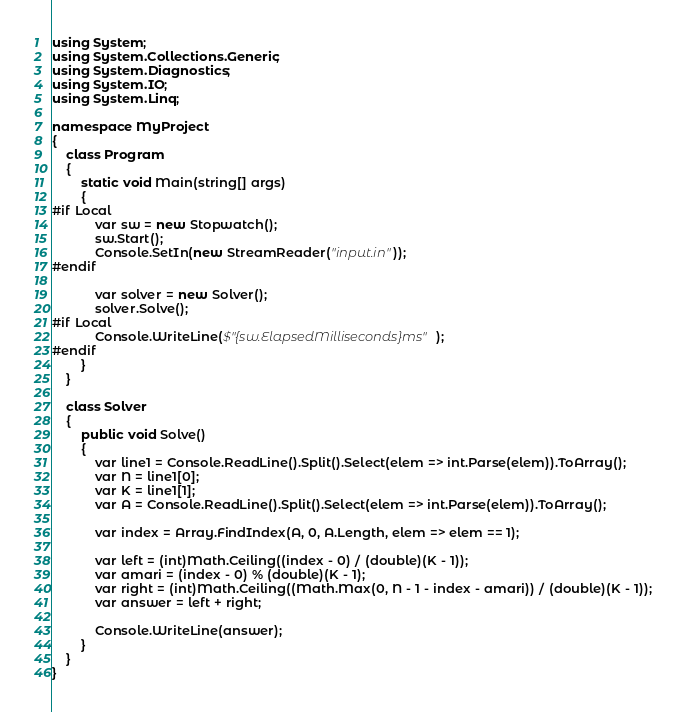<code> <loc_0><loc_0><loc_500><loc_500><_C#_>using System;
using System.Collections.Generic;
using System.Diagnostics;
using System.IO;
using System.Linq;

namespace MyProject
{
    class Program
    {
        static void Main(string[] args)
        {
#if Local
            var sw = new Stopwatch();
            sw.Start();
            Console.SetIn(new StreamReader("input.in"));
#endif

            var solver = new Solver();
            solver.Solve();
#if Local
            Console.WriteLine($"{sw.ElapsedMilliseconds}ms");
#endif
        }
    }

    class Solver
    {
        public void Solve()
        {
            var line1 = Console.ReadLine().Split().Select(elem => int.Parse(elem)).ToArray();
            var N = line1[0];
            var K = line1[1];
            var A = Console.ReadLine().Split().Select(elem => int.Parse(elem)).ToArray();

            var index = Array.FindIndex(A, 0, A.Length, elem => elem == 1);

            var left = (int)Math.Ceiling((index - 0) / (double)(K - 1));
            var amari = (index - 0) % (double)(K - 1);
            var right = (int)Math.Ceiling((Math.Max(0, N - 1 - index - amari)) / (double)(K - 1));
            var answer = left + right;

            Console.WriteLine(answer);
        }
    }
}
</code> 